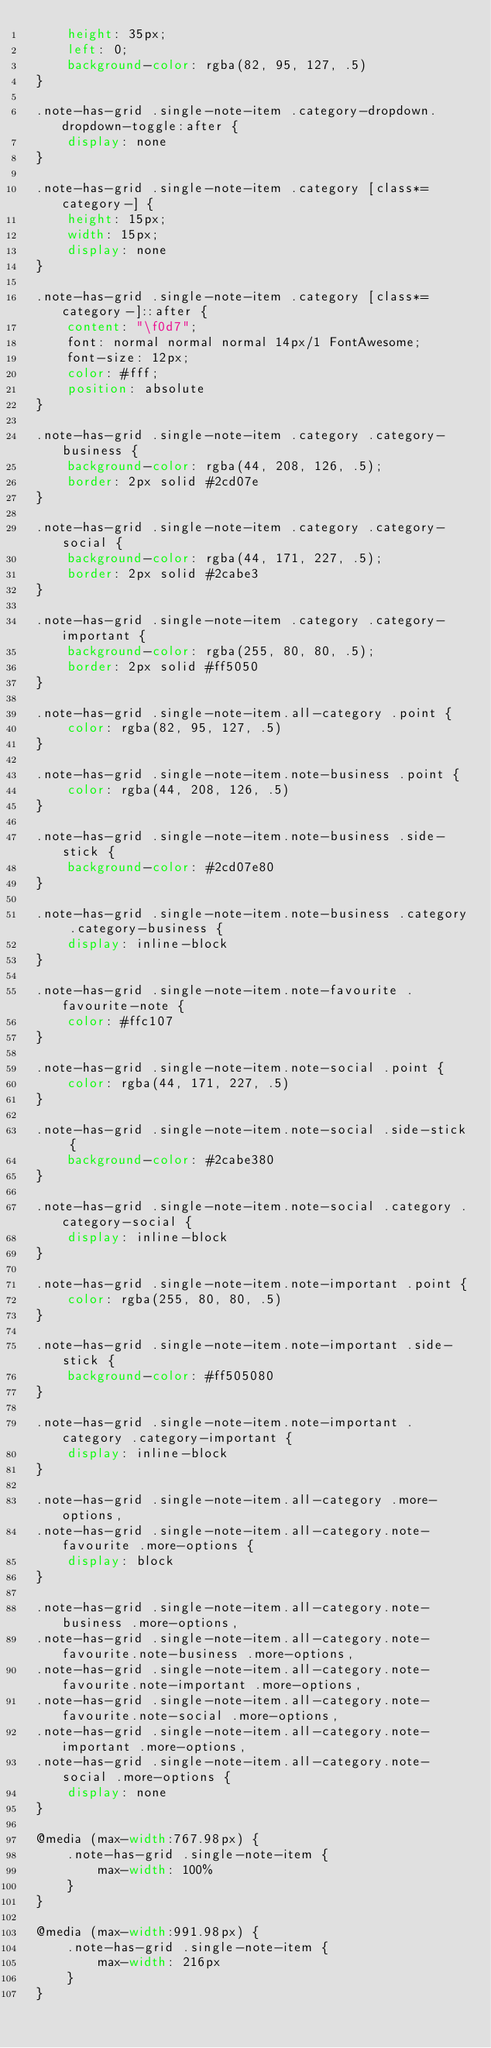<code> <loc_0><loc_0><loc_500><loc_500><_CSS_>     height: 35px;
     left: 0;
     background-color: rgba(82, 95, 127, .5)
 }

 .note-has-grid .single-note-item .category-dropdown.dropdown-toggle:after {
     display: none
 }

 .note-has-grid .single-note-item .category [class*=category-] {
     height: 15px;
     width: 15px;
     display: none
 }

 .note-has-grid .single-note-item .category [class*=category-]::after {
     content: "\f0d7";
     font: normal normal normal 14px/1 FontAwesome;
     font-size: 12px;
     color: #fff;
     position: absolute
 }

 .note-has-grid .single-note-item .category .category-business {
     background-color: rgba(44, 208, 126, .5);
     border: 2px solid #2cd07e
 }

 .note-has-grid .single-note-item .category .category-social {
     background-color: rgba(44, 171, 227, .5);
     border: 2px solid #2cabe3
 }

 .note-has-grid .single-note-item .category .category-important {
     background-color: rgba(255, 80, 80, .5);
     border: 2px solid #ff5050
 }

 .note-has-grid .single-note-item.all-category .point {
     color: rgba(82, 95, 127, .5)
 }

 .note-has-grid .single-note-item.note-business .point {
     color: rgba(44, 208, 126, .5)
 }

 .note-has-grid .single-note-item.note-business .side-stick {
     background-color: #2cd07e80
 }

 .note-has-grid .single-note-item.note-business .category .category-business {
     display: inline-block
 }

 .note-has-grid .single-note-item.note-favourite .favourite-note {
     color: #ffc107
 }

 .note-has-grid .single-note-item.note-social .point {
     color: rgba(44, 171, 227, .5)
 }

 .note-has-grid .single-note-item.note-social .side-stick {
     background-color: #2cabe380
 }

 .note-has-grid .single-note-item.note-social .category .category-social {
     display: inline-block
 }

 .note-has-grid .single-note-item.note-important .point {
     color: rgba(255, 80, 80, .5)
 }

 .note-has-grid .single-note-item.note-important .side-stick {
     background-color: #ff505080
 }

 .note-has-grid .single-note-item.note-important .category .category-important {
     display: inline-block
 }

 .note-has-grid .single-note-item.all-category .more-options,
 .note-has-grid .single-note-item.all-category.note-favourite .more-options {
     display: block
 }

 .note-has-grid .single-note-item.all-category.note-business .more-options,
 .note-has-grid .single-note-item.all-category.note-favourite.note-business .more-options,
 .note-has-grid .single-note-item.all-category.note-favourite.note-important .more-options,
 .note-has-grid .single-note-item.all-category.note-favourite.note-social .more-options,
 .note-has-grid .single-note-item.all-category.note-important .more-options,
 .note-has-grid .single-note-item.all-category.note-social .more-options {
     display: none
 }

 @media (max-width:767.98px) {
     .note-has-grid .single-note-item {
         max-width: 100%
     }
 }

 @media (max-width:991.98px) {
     .note-has-grid .single-note-item {
         max-width: 216px
     }
 }
</code> 